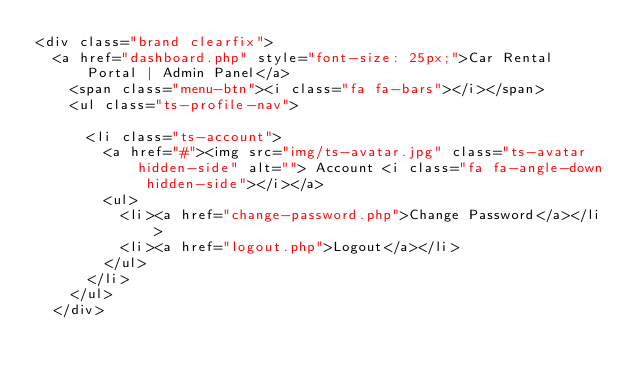<code> <loc_0><loc_0><loc_500><loc_500><_PHP_><div class="brand clearfix">
	<a href="dashboard.php" style="font-size: 25px;">Car Rental Portal | Admin Panel</a>  
		<span class="menu-btn"><i class="fa fa-bars"></i></span>
		<ul class="ts-profile-nav">
			
			<li class="ts-account">
				<a href="#"><img src="img/ts-avatar.jpg" class="ts-avatar hidden-side" alt=""> Account <i class="fa fa-angle-down hidden-side"></i></a>
				<ul>
					<li><a href="change-password.php">Change Password</a></li>
					<li><a href="logout.php">Logout</a></li>
				</ul>
			</li>
		</ul>
	</div>
</code> 